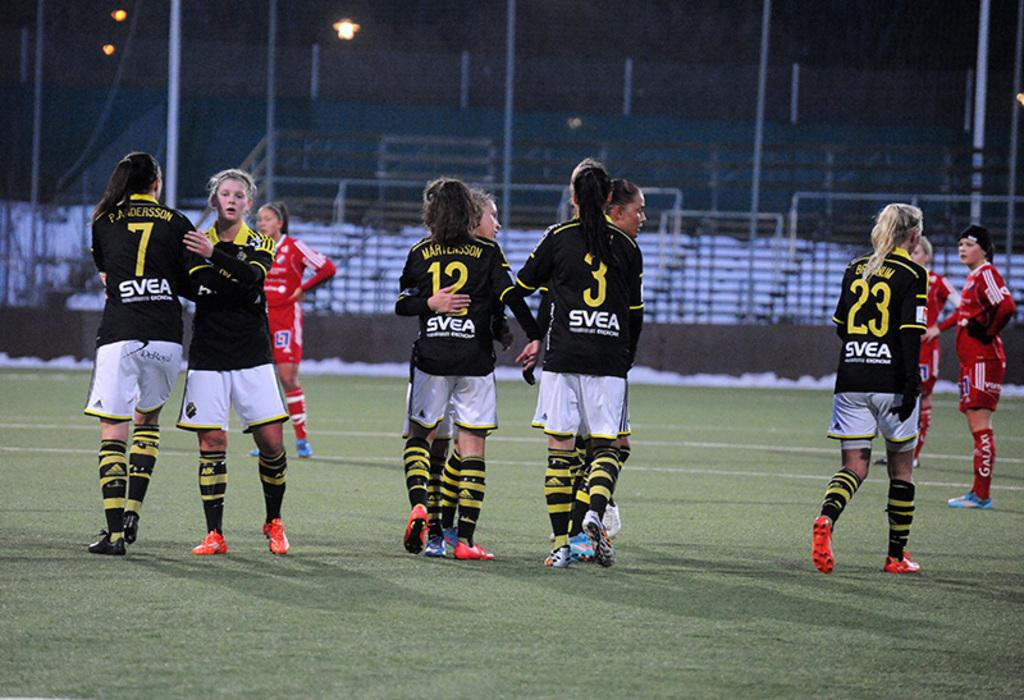<image>
Share a concise interpretation of the image provided. A player pats player number 7 on the shoulder. 